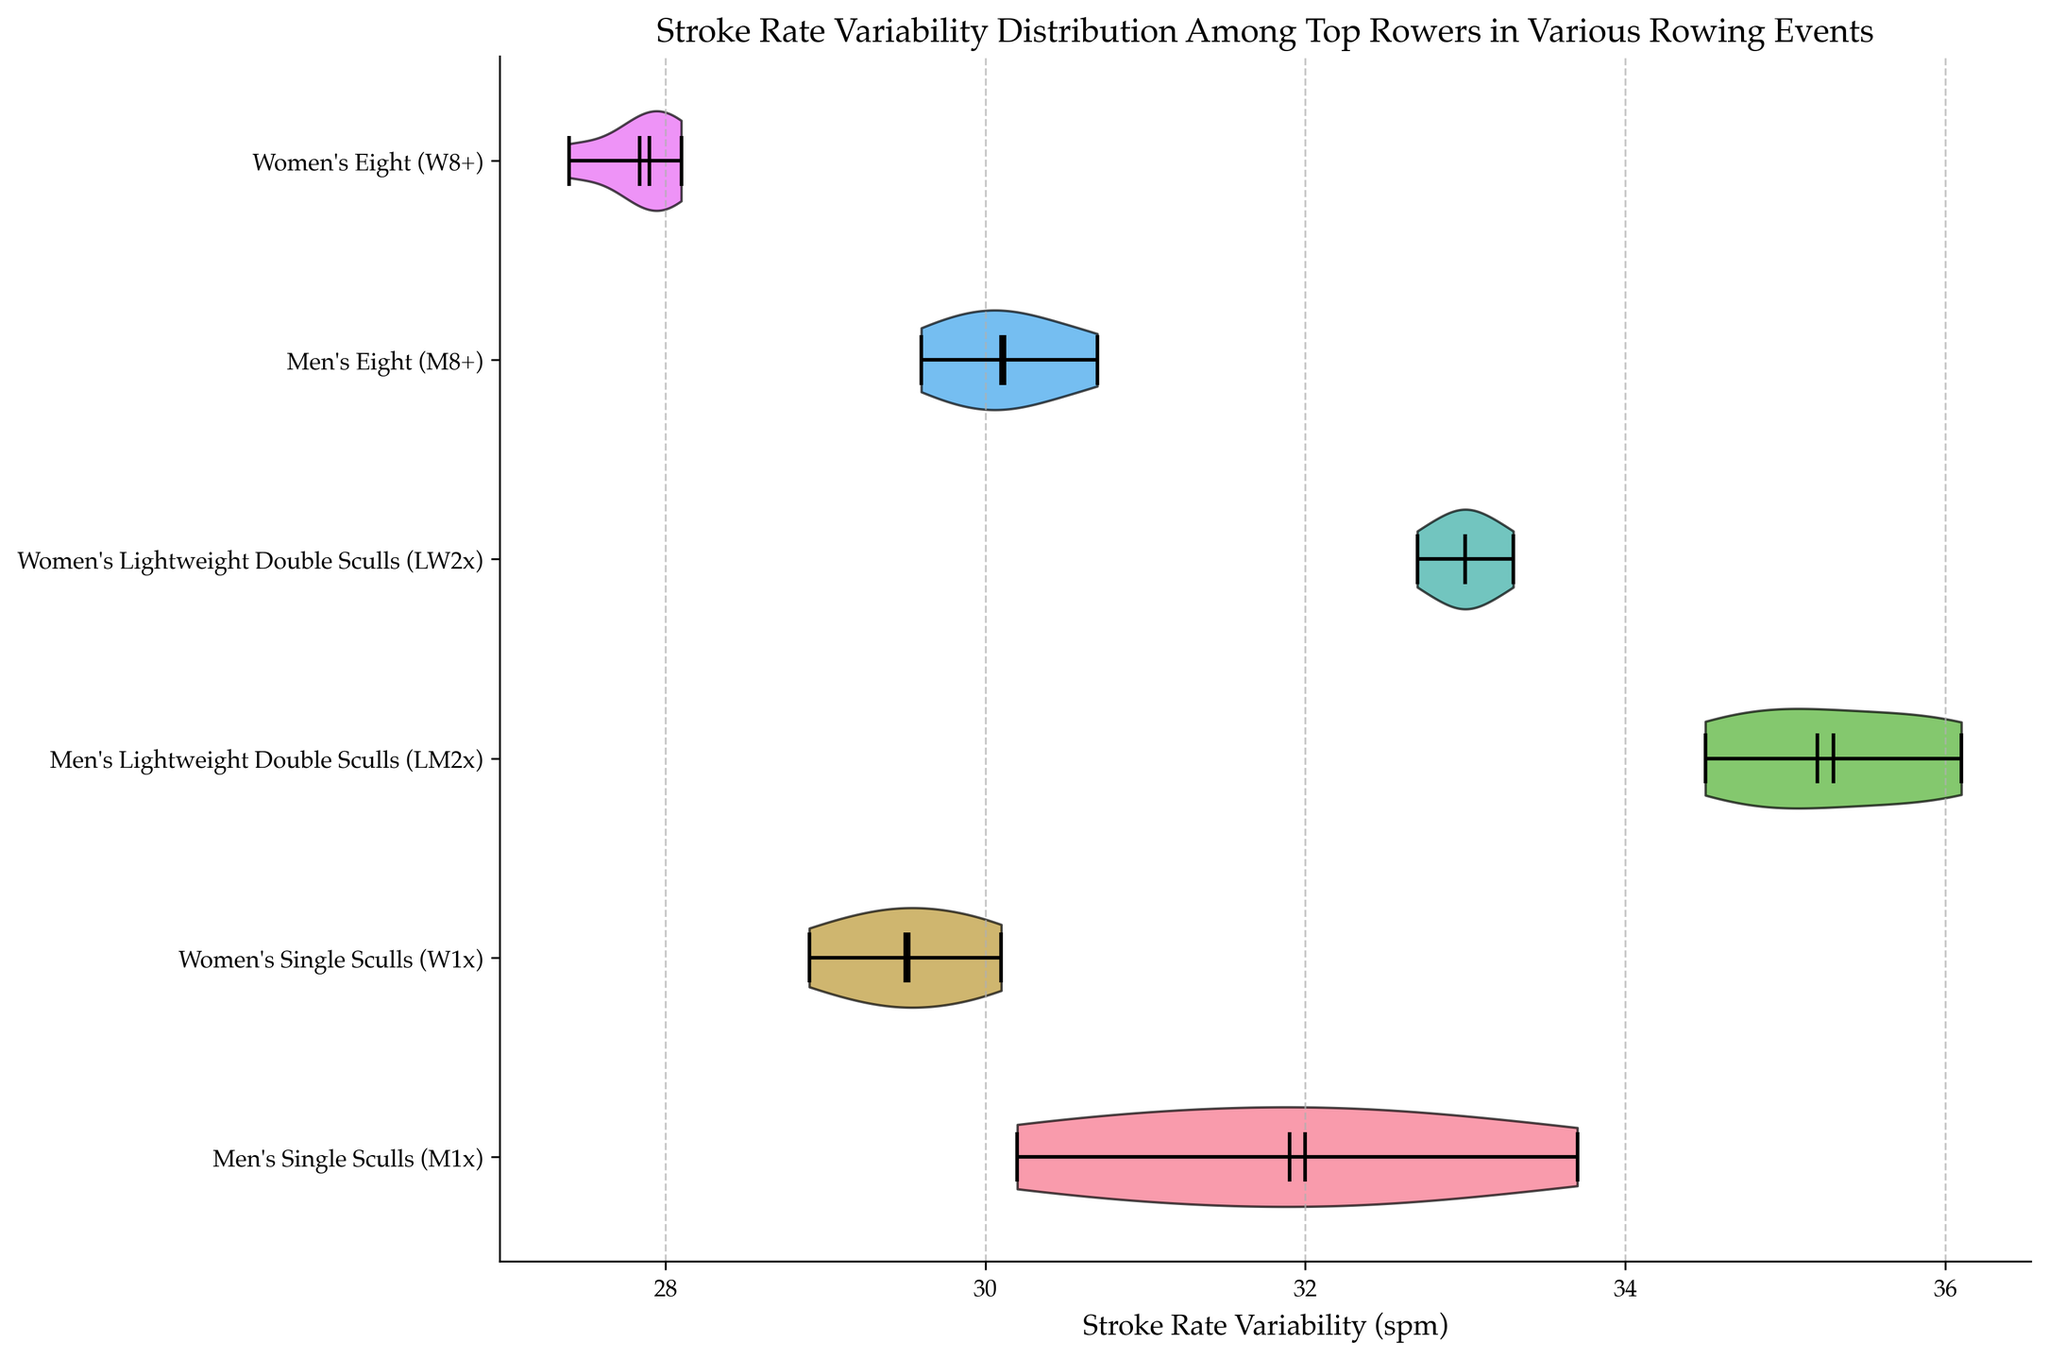How many events are being analyzed in the chart? The chart shows stroke rate variability for different rowing events, each event has a corresponding violin plot. By counting the unique events along the y-axis, we determine there are 6 events.
Answer: 6 What is the title of the chart? The title of the chart is located above the plotting area and provides a summary of the chart's content.
Answer: Stroke Rate Variability Distribution Among Top Rowers in Various Rowing Events Which rowing event has the highest median stroke rate variability? To determine this, look for the violin plot with the highest median line along the x-axis.
Answer: Men's Lightweight Double Sculls (LM2x) Which event has the lowest mean stroke rate variability? Observe the small markings within each violin plot. The mean is usually indicated distinctively, often by a dot or line. The lowest mean marking along the x-axis indicates the event with the lowest mean stroke rate variability.
Answer: Women's Eight (W8+) Compare the stroke rate variability distribution between Men's Single Sculls (M1x) and Women's Single Sculls (W1x). Which event shows a higher variability in the data distribution? Examine the shape and spread of the violin plots for Men's Single Sculls (M1x) and Women's Single Sculls (W1x). The plot that stretches wider along the x-axis indicates higher variability.
Answer: Men's Single Sculls (M1x) What is the interquartile range (IQR) for Women’s Lightweight Double Sculls (LW2x)? The interquartile range is the distance between the first quartile (Q1) and the third quartile (Q3). These can be inferred from the spread of the violin plot from the ends of the thicker middle section.
Answer: Approximately 1.0 spm Which event has the most symmetrical stroke rate variability distribution? Symmetrical distribution can be identified by looking at the violin plots that are evenly shaped on both sides of the median line.
Answer: Women's Single Sculls (W1x) What is the general trend in stroke rate variability between lightweight and heavyweight rowing events? Compare the broader trends in the stroke variabilities by observing the violin plots for lightweight (LM and LW) vs. heavyweight (M1x and W1x, M8+ and W8+) categories. The general trend can be noted by the central tendencies (mean and median) and the spread of the distributions.
Answer: Lightweight events generally show higher variability Which event has the widest distribution in terms of stroke rate variability? To determine the event with the widest distribution, look for the most elongated violin plot along the x-axis.
Answer: Men's Lightweight Double Sculls (LM2x) Between Men's Eight (M8+) and Women's Eight (W8+), which one has the higher median stroke rate variability? Compare the median line positions of the violin plots for Men's Eight (M8+) and Women's Eight (W8+). The event with the median line further to the right has a higher median stroke rate variability.
Answer: Men's Eight (M8+) 